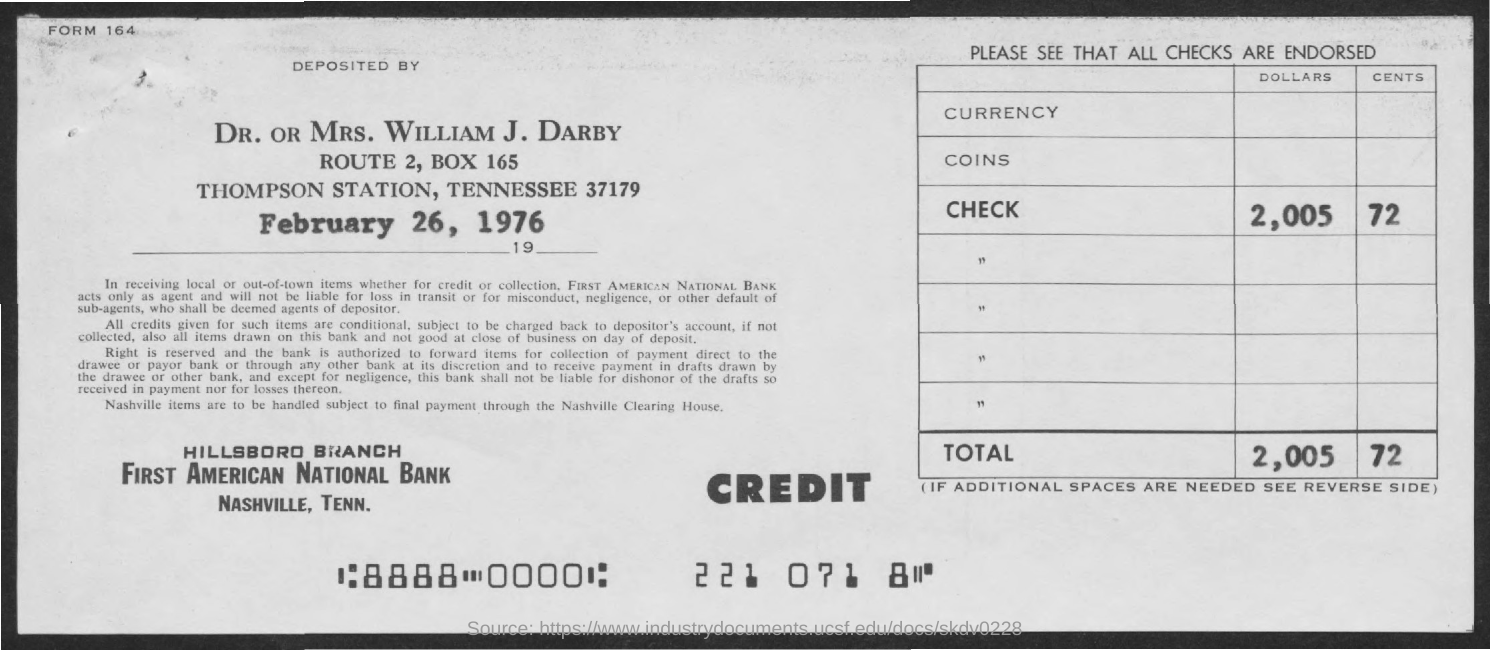The amount is deposited on which date?
Offer a terse response. February 26,1976. 